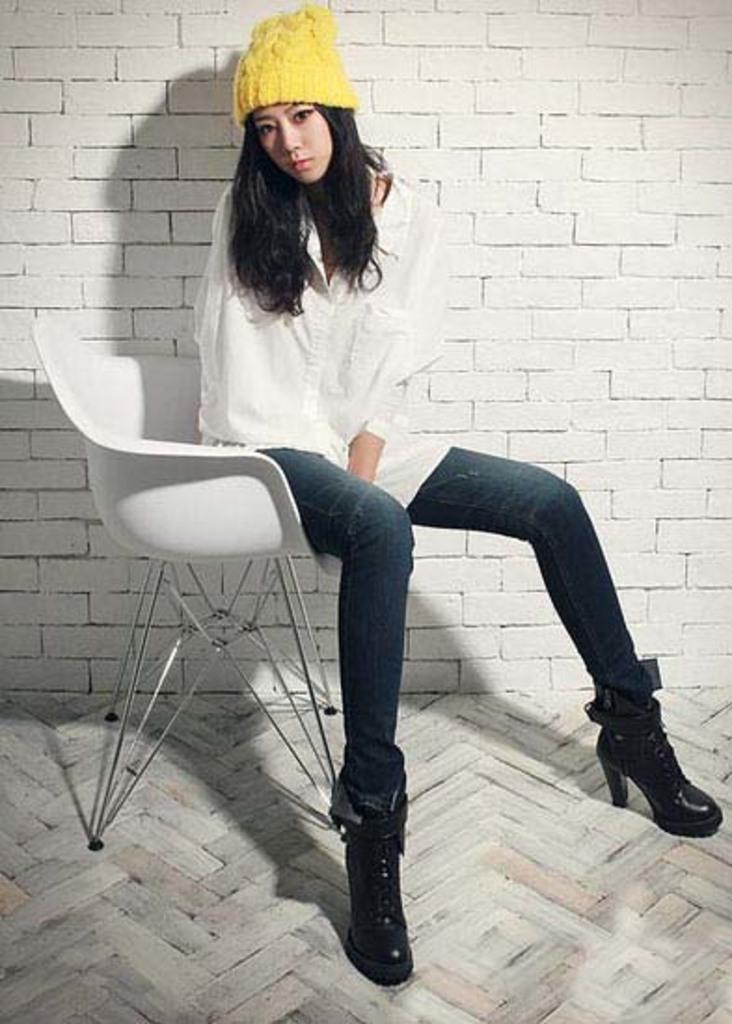In one or two sentences, can you explain what this image depicts? She is sitting on a chair. She is wearing a cap. There is a carpet on the floor. We can see in the background white color brick wall. 